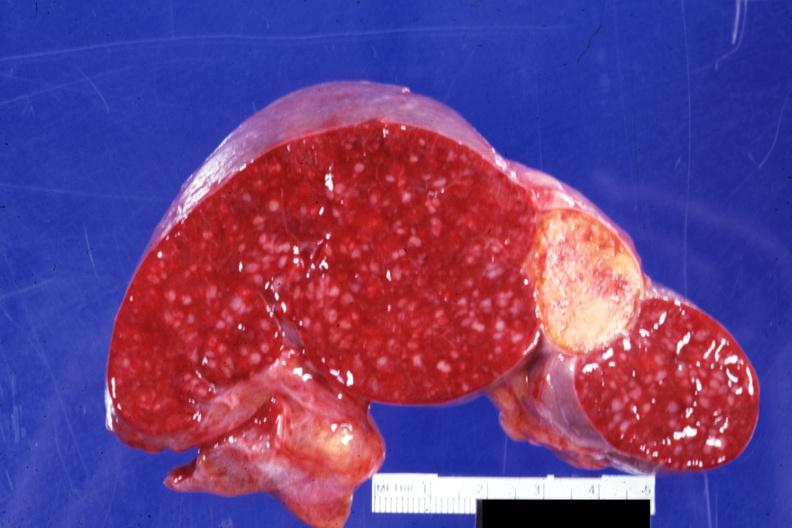how is cut surface with remote and now healed infarct quite embolus for aortic valve prosthesis?
Answer the question using a single word or phrase. Typical 